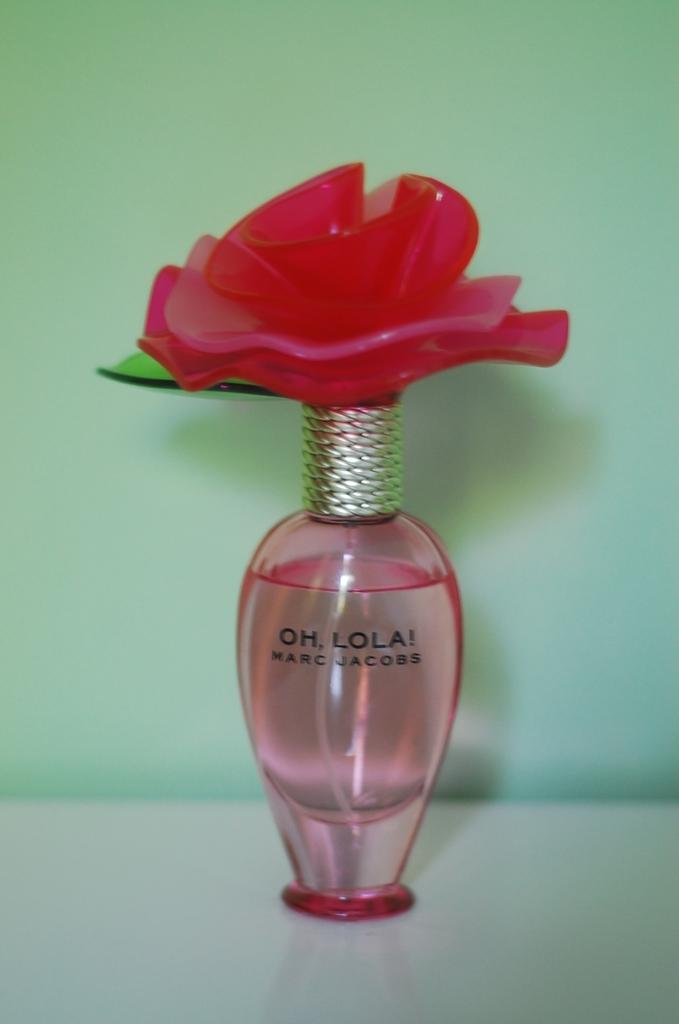<image>
Provide a brief description of the given image. Perfume bottle with a rose shaped cap by Marc Jacobs. 